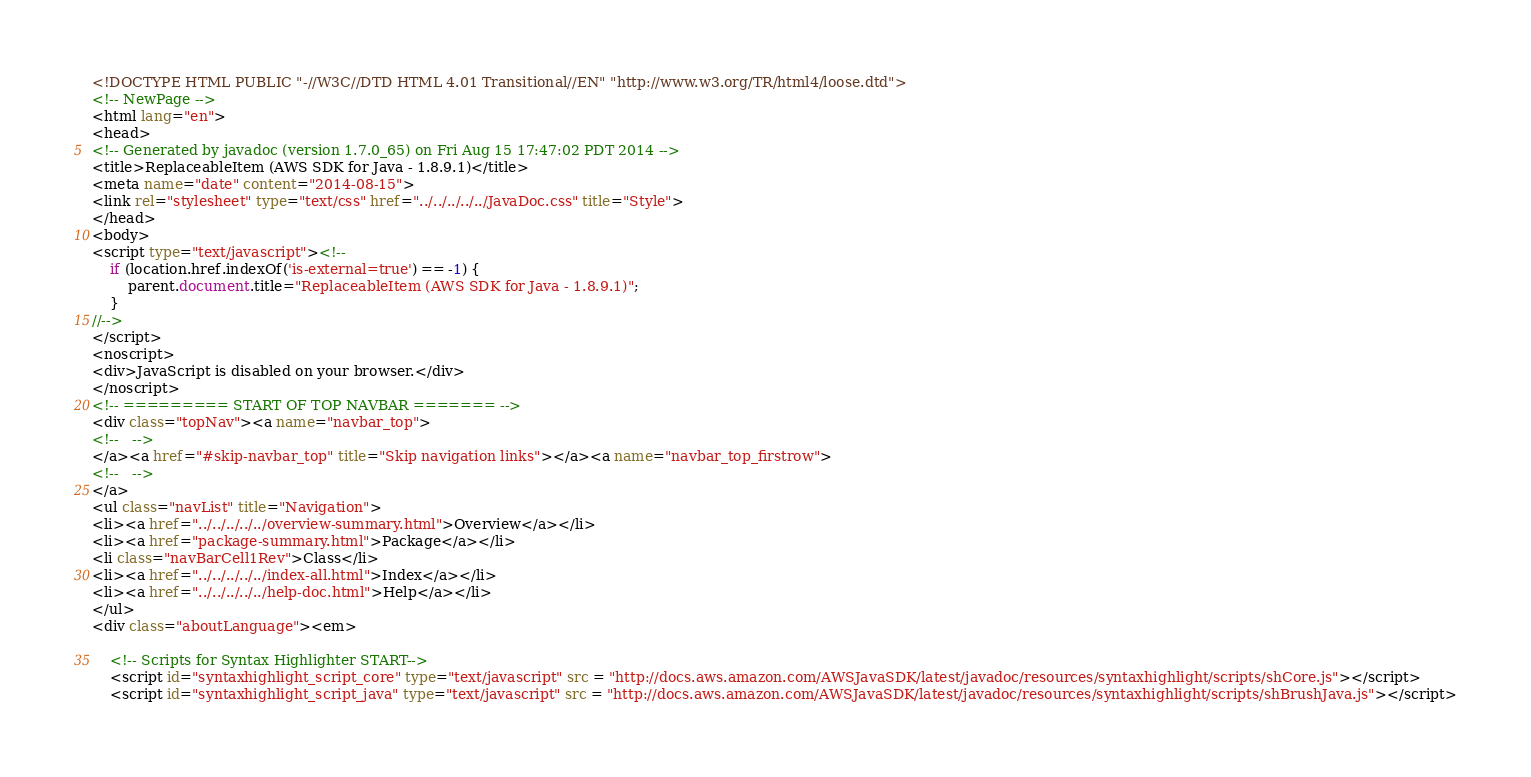<code> <loc_0><loc_0><loc_500><loc_500><_HTML_><!DOCTYPE HTML PUBLIC "-//W3C//DTD HTML 4.01 Transitional//EN" "http://www.w3.org/TR/html4/loose.dtd">
<!-- NewPage -->
<html lang="en">
<head>
<!-- Generated by javadoc (version 1.7.0_65) on Fri Aug 15 17:47:02 PDT 2014 -->
<title>ReplaceableItem (AWS SDK for Java - 1.8.9.1)</title>
<meta name="date" content="2014-08-15">
<link rel="stylesheet" type="text/css" href="../../../../../JavaDoc.css" title="Style">
</head>
<body>
<script type="text/javascript"><!--
    if (location.href.indexOf('is-external=true') == -1) {
        parent.document.title="ReplaceableItem (AWS SDK for Java - 1.8.9.1)";
    }
//-->
</script>
<noscript>
<div>JavaScript is disabled on your browser.</div>
</noscript>
<!-- ========= START OF TOP NAVBAR ======= -->
<div class="topNav"><a name="navbar_top">
<!--   -->
</a><a href="#skip-navbar_top" title="Skip navigation links"></a><a name="navbar_top_firstrow">
<!--   -->
</a>
<ul class="navList" title="Navigation">
<li><a href="../../../../../overview-summary.html">Overview</a></li>
<li><a href="package-summary.html">Package</a></li>
<li class="navBarCell1Rev">Class</li>
<li><a href="../../../../../index-all.html">Index</a></li>
<li><a href="../../../../../help-doc.html">Help</a></li>
</ul>
<div class="aboutLanguage"><em>

    <!-- Scripts for Syntax Highlighter START-->
    <script id="syntaxhighlight_script_core" type="text/javascript" src = "http://docs.aws.amazon.com/AWSJavaSDK/latest/javadoc/resources/syntaxhighlight/scripts/shCore.js"></script>
    <script id="syntaxhighlight_script_java" type="text/javascript" src = "http://docs.aws.amazon.com/AWSJavaSDK/latest/javadoc/resources/syntaxhighlight/scripts/shBrushJava.js"></script></code> 